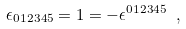Convert formula to latex. <formula><loc_0><loc_0><loc_500><loc_500>\epsilon _ { 0 1 2 3 4 5 } = 1 = - \epsilon ^ { 0 1 2 3 4 5 } \ ,</formula> 